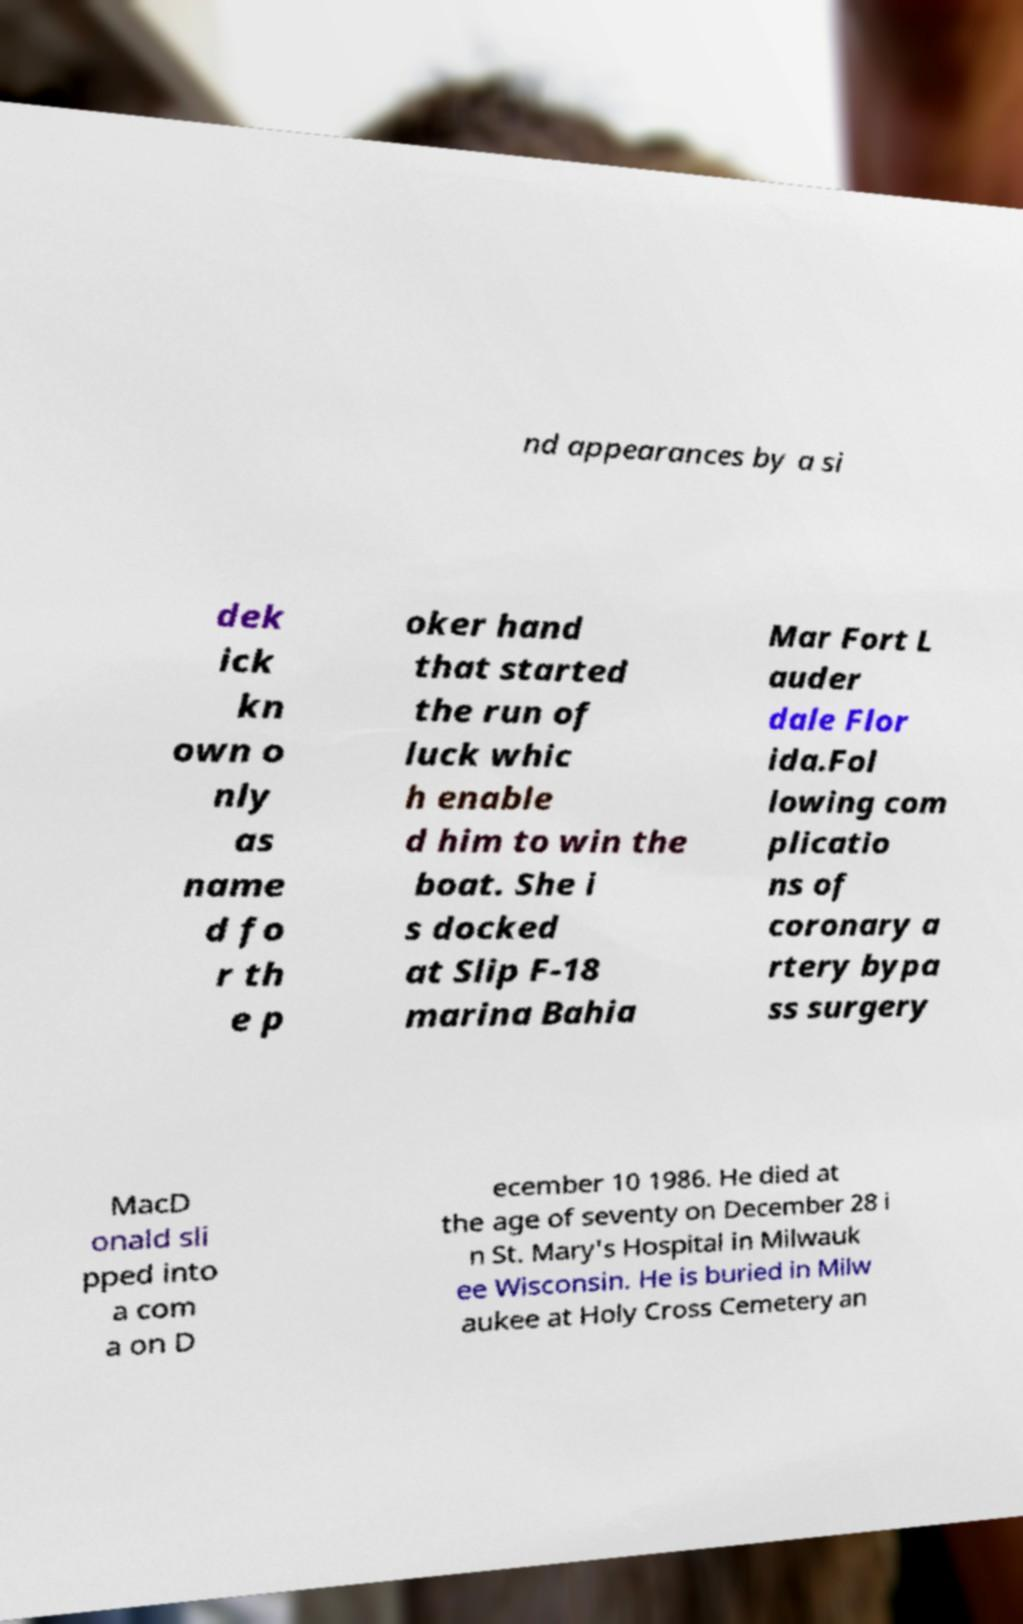For documentation purposes, I need the text within this image transcribed. Could you provide that? nd appearances by a si dek ick kn own o nly as name d fo r th e p oker hand that started the run of luck whic h enable d him to win the boat. She i s docked at Slip F-18 marina Bahia Mar Fort L auder dale Flor ida.Fol lowing com plicatio ns of coronary a rtery bypa ss surgery MacD onald sli pped into a com a on D ecember 10 1986. He died at the age of seventy on December 28 i n St. Mary's Hospital in Milwauk ee Wisconsin. He is buried in Milw aukee at Holy Cross Cemetery an 